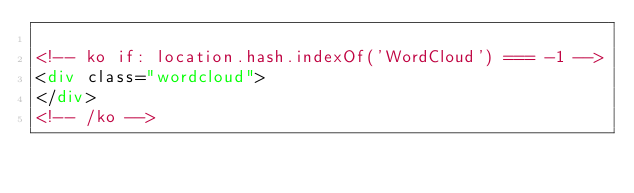Convert code to text. <code><loc_0><loc_0><loc_500><loc_500><_HTML_>
<!-- ko if: location.hash.indexOf('WordCloud') === -1 -->
<div class="wordcloud">
</div>
<!-- /ko --></code> 